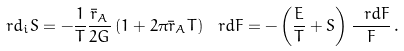<formula> <loc_0><loc_0><loc_500><loc_500>\ r d _ { i } S = - \frac { 1 } { T } \frac { \bar { r } _ { A } } { 2 G } \left ( 1 + 2 \pi \bar { r } _ { A } T \right ) \ r d F = - \left ( \frac { E } { T } + S \right ) \frac { \ r d F } { F } \, .</formula> 